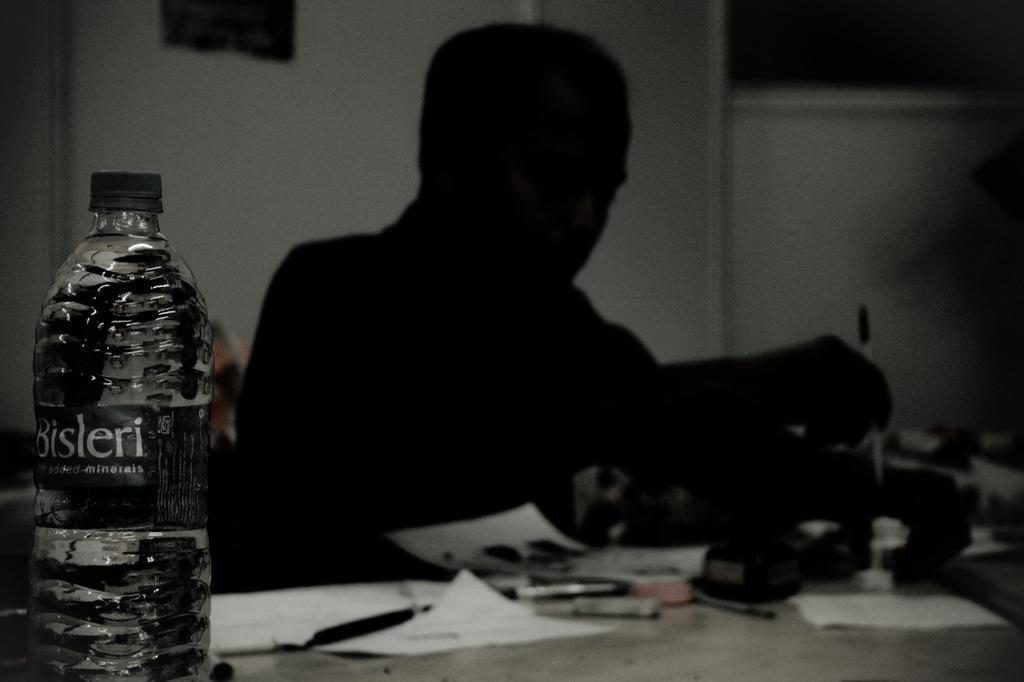Describe this image in one or two sentences. In this picture we can see a bottle and a person in front of him we can see a paper, pen and some other objects. 